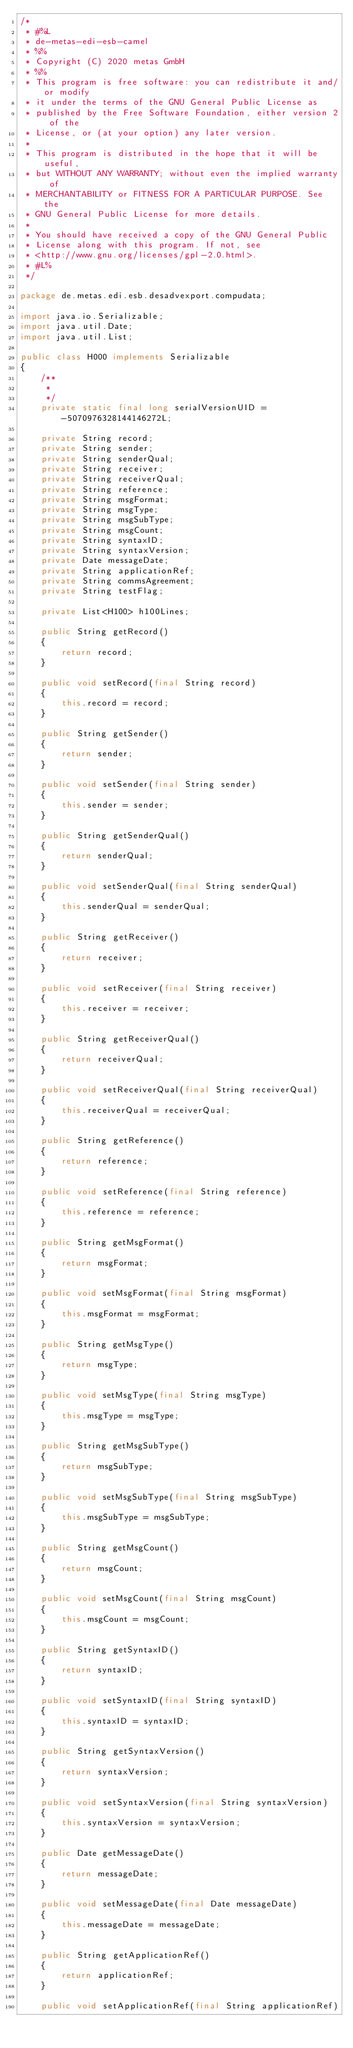<code> <loc_0><loc_0><loc_500><loc_500><_Java_>/*
 * #%L
 * de-metas-edi-esb-camel
 * %%
 * Copyright (C) 2020 metas GmbH
 * %%
 * This program is free software: you can redistribute it and/or modify
 * it under the terms of the GNU General Public License as
 * published by the Free Software Foundation, either version 2 of the
 * License, or (at your option) any later version.
 *
 * This program is distributed in the hope that it will be useful,
 * but WITHOUT ANY WARRANTY; without even the implied warranty of
 * MERCHANTABILITY or FITNESS FOR A PARTICULAR PURPOSE. See the
 * GNU General Public License for more details.
 *
 * You should have received a copy of the GNU General Public
 * License along with this program. If not, see
 * <http://www.gnu.org/licenses/gpl-2.0.html>.
 * #L%
 */

package de.metas.edi.esb.desadvexport.compudata;

import java.io.Serializable;
import java.util.Date;
import java.util.List;

public class H000 implements Serializable
{
	/**
	 * 
	 */
	private static final long serialVersionUID = -5070976328144146272L;

	private String record;
	private String sender;
	private String senderQual;
	private String receiver;
	private String receiverQual;
	private String reference;
	private String msgFormat;
	private String msgType;
	private String msgSubType;
	private String msgCount;
	private String syntaxID;
	private String syntaxVersion;
	private Date messageDate;
	private String applicationRef;
	private String commsAgreement;
	private String testFlag;

	private List<H100> h100Lines;

	public String getRecord()
	{
		return record;
	}

	public void setRecord(final String record)
	{
		this.record = record;
	}

	public String getSender()
	{
		return sender;
	}

	public void setSender(final String sender)
	{
		this.sender = sender;
	}

	public String getSenderQual()
	{
		return senderQual;
	}

	public void setSenderQual(final String senderQual)
	{
		this.senderQual = senderQual;
	}

	public String getReceiver()
	{
		return receiver;
	}

	public void setReceiver(final String receiver)
	{
		this.receiver = receiver;
	}

	public String getReceiverQual()
	{
		return receiverQual;
	}

	public void setReceiverQual(final String receiverQual)
	{
		this.receiverQual = receiverQual;
	}

	public String getReference()
	{
		return reference;
	}

	public void setReference(final String reference)
	{
		this.reference = reference;
	}

	public String getMsgFormat()
	{
		return msgFormat;
	}

	public void setMsgFormat(final String msgFormat)
	{
		this.msgFormat = msgFormat;
	}

	public String getMsgType()
	{
		return msgType;
	}

	public void setMsgType(final String msgType)
	{
		this.msgType = msgType;
	}

	public String getMsgSubType()
	{
		return msgSubType;
	}

	public void setMsgSubType(final String msgSubType)
	{
		this.msgSubType = msgSubType;
	}

	public String getMsgCount()
	{
		return msgCount;
	}

	public void setMsgCount(final String msgCount)
	{
		this.msgCount = msgCount;
	}

	public String getSyntaxID()
	{
		return syntaxID;
	}

	public void setSyntaxID(final String syntaxID)
	{
		this.syntaxID = syntaxID;
	}

	public String getSyntaxVersion()
	{
		return syntaxVersion;
	}

	public void setSyntaxVersion(final String syntaxVersion)
	{
		this.syntaxVersion = syntaxVersion;
	}

	public Date getMessageDate()
	{
		return messageDate;
	}

	public void setMessageDate(final Date messageDate)
	{
		this.messageDate = messageDate;
	}

	public String getApplicationRef()
	{
		return applicationRef;
	}

	public void setApplicationRef(final String applicationRef)</code> 